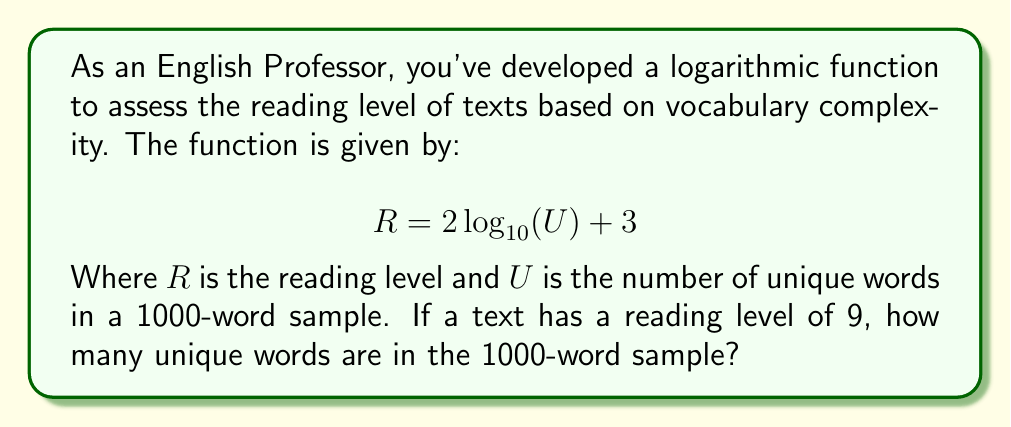Can you solve this math problem? Let's approach this step-by-step:

1) We're given the function: $R = 2\log_{10}(U) + 3$

2) We know that $R = 9$ (the reading level), and we need to find $U$ (unique words).

3) Let's substitute $R = 9$ into the equation:

   $9 = 2\log_{10}(U) + 3$

4) Subtract 3 from both sides:

   $6 = 2\log_{10}(U)$

5) Divide both sides by 2:

   $3 = \log_{10}(U)$

6) Now, we need to solve for $U$. We can do this by applying the inverse function (exponential) to both sides:

   $10^3 = U$

7) Calculate:

   $1000 = U$

Therefore, there are 1000 unique words in the 1000-word sample.
Answer: 1000 unique words 